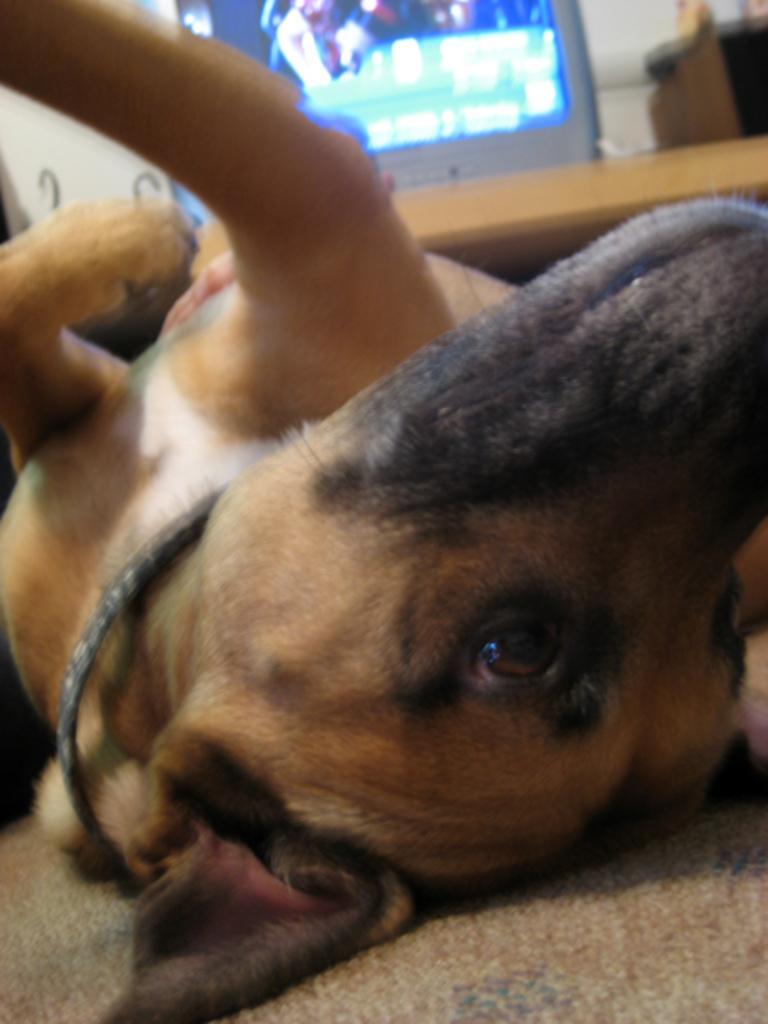Describe this image in one or two sentences. In this image we can see a dog lying on the floor, there is a TV, and a box on the table, also we can see the sky. 